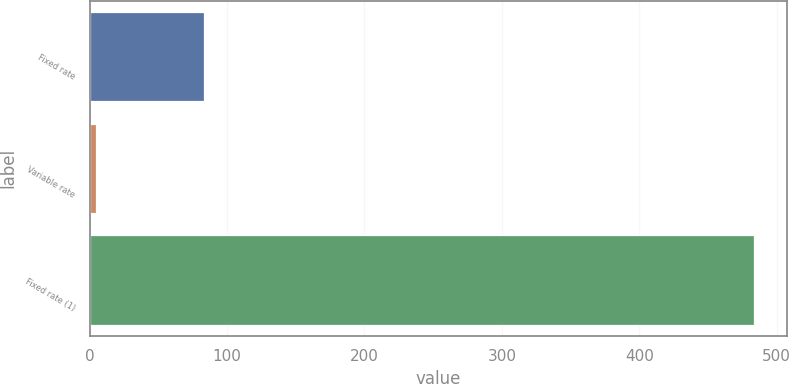Convert chart to OTSL. <chart><loc_0><loc_0><loc_500><loc_500><bar_chart><fcel>Fixed rate<fcel>Variable rate<fcel>Fixed rate (1)<nl><fcel>83.5<fcel>4.4<fcel>483.6<nl></chart> 